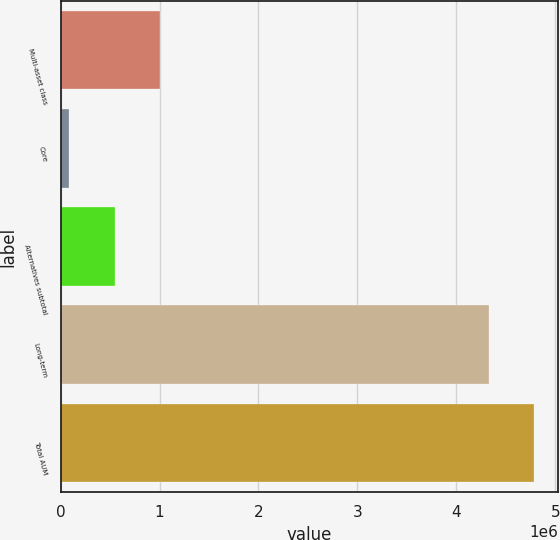Convert chart to OTSL. <chart><loc_0><loc_0><loc_500><loc_500><bar_chart><fcel>Multi-asset class<fcel>Core<fcel>Alternatives subtotal<fcel>Long-term<fcel>Total AUM<nl><fcel>1.00078e+06<fcel>88006<fcel>544395<fcel>4.33384e+06<fcel>4.79023e+06<nl></chart> 